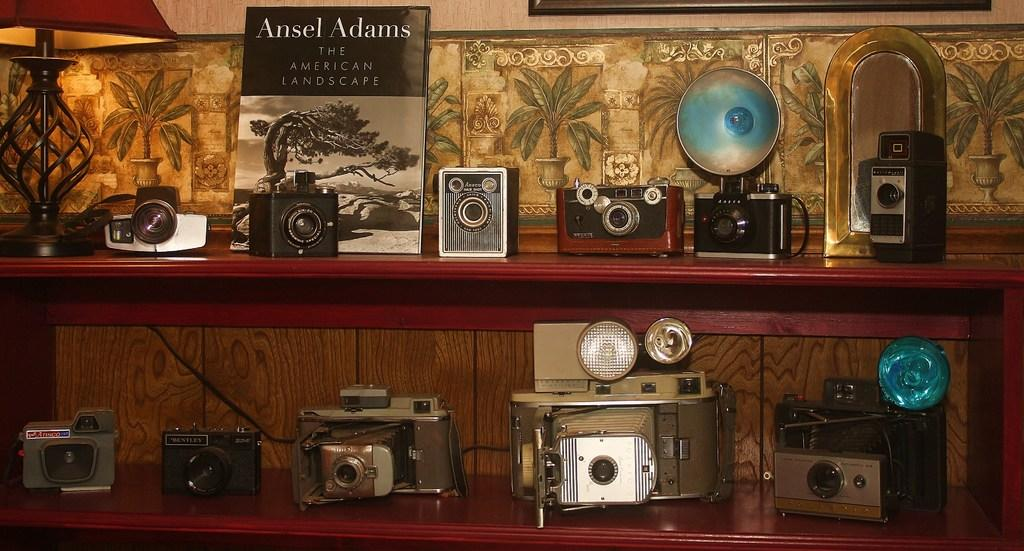<image>
Relay a brief, clear account of the picture shown. shelves of old cameras along with a book by ansel adams 